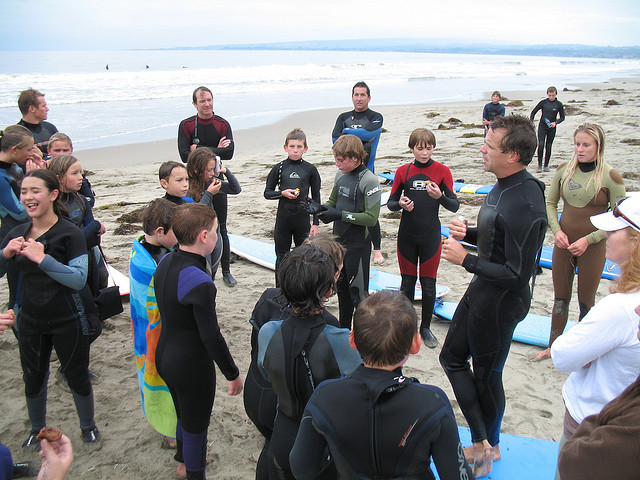Please transcribe the text information in this image. 8 